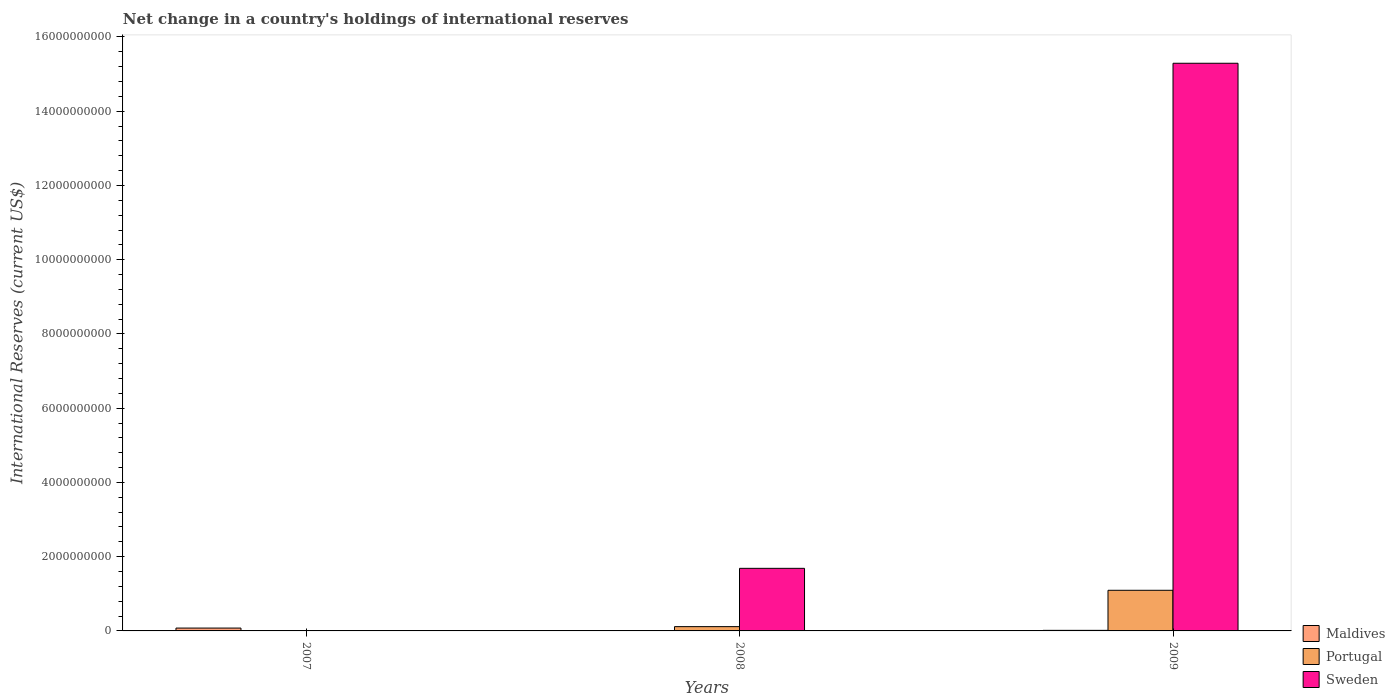Are the number of bars per tick equal to the number of legend labels?
Offer a terse response. No. How many bars are there on the 1st tick from the left?
Your answer should be very brief. 1. What is the label of the 2nd group of bars from the left?
Your answer should be very brief. 2008. What is the international reserves in Maldives in 2009?
Provide a succinct answer. 1.54e+07. Across all years, what is the maximum international reserves in Sweden?
Provide a short and direct response. 1.53e+1. Across all years, what is the minimum international reserves in Sweden?
Ensure brevity in your answer.  0. What is the total international reserves in Sweden in the graph?
Make the answer very short. 1.70e+1. What is the difference between the international reserves in Maldives in 2007 and that in 2009?
Offer a terse response. 6.13e+07. What is the difference between the international reserves in Sweden in 2008 and the international reserves in Portugal in 2009?
Offer a very short reply. 5.91e+08. What is the average international reserves in Sweden per year?
Provide a succinct answer. 5.66e+09. In the year 2009, what is the difference between the international reserves in Portugal and international reserves in Maldives?
Keep it short and to the point. 1.08e+09. Is the international reserves in Sweden in 2008 less than that in 2009?
Make the answer very short. Yes. What is the difference between the highest and the lowest international reserves in Sweden?
Offer a very short reply. 1.53e+1. Is it the case that in every year, the sum of the international reserves in Sweden and international reserves in Maldives is greater than the international reserves in Portugal?
Your answer should be compact. Yes. How many bars are there?
Offer a terse response. 6. Are all the bars in the graph horizontal?
Your answer should be compact. No. Does the graph contain any zero values?
Provide a short and direct response. Yes. How many legend labels are there?
Your answer should be compact. 3. How are the legend labels stacked?
Your answer should be compact. Vertical. What is the title of the graph?
Make the answer very short. Net change in a country's holdings of international reserves. What is the label or title of the Y-axis?
Offer a terse response. International Reserves (current US$). What is the International Reserves (current US$) in Maldives in 2007?
Your response must be concise. 7.67e+07. What is the International Reserves (current US$) of Portugal in 2007?
Your answer should be very brief. 0. What is the International Reserves (current US$) in Sweden in 2007?
Your answer should be compact. 0. What is the International Reserves (current US$) of Maldives in 2008?
Provide a succinct answer. 0. What is the International Reserves (current US$) of Portugal in 2008?
Provide a short and direct response. 1.15e+08. What is the International Reserves (current US$) in Sweden in 2008?
Your response must be concise. 1.69e+09. What is the International Reserves (current US$) in Maldives in 2009?
Make the answer very short. 1.54e+07. What is the International Reserves (current US$) in Portugal in 2009?
Offer a terse response. 1.09e+09. What is the International Reserves (current US$) in Sweden in 2009?
Provide a succinct answer. 1.53e+1. Across all years, what is the maximum International Reserves (current US$) of Maldives?
Ensure brevity in your answer.  7.67e+07. Across all years, what is the maximum International Reserves (current US$) in Portugal?
Ensure brevity in your answer.  1.09e+09. Across all years, what is the maximum International Reserves (current US$) of Sweden?
Make the answer very short. 1.53e+1. Across all years, what is the minimum International Reserves (current US$) in Maldives?
Your answer should be very brief. 0. Across all years, what is the minimum International Reserves (current US$) of Sweden?
Offer a very short reply. 0. What is the total International Reserves (current US$) of Maldives in the graph?
Give a very brief answer. 9.21e+07. What is the total International Reserves (current US$) in Portugal in the graph?
Make the answer very short. 1.21e+09. What is the total International Reserves (current US$) of Sweden in the graph?
Ensure brevity in your answer.  1.70e+1. What is the difference between the International Reserves (current US$) in Maldives in 2007 and that in 2009?
Your answer should be compact. 6.13e+07. What is the difference between the International Reserves (current US$) in Portugal in 2008 and that in 2009?
Provide a succinct answer. -9.79e+08. What is the difference between the International Reserves (current US$) of Sweden in 2008 and that in 2009?
Keep it short and to the point. -1.36e+1. What is the difference between the International Reserves (current US$) in Maldives in 2007 and the International Reserves (current US$) in Portugal in 2008?
Your answer should be very brief. -3.87e+07. What is the difference between the International Reserves (current US$) of Maldives in 2007 and the International Reserves (current US$) of Sweden in 2008?
Provide a short and direct response. -1.61e+09. What is the difference between the International Reserves (current US$) in Maldives in 2007 and the International Reserves (current US$) in Portugal in 2009?
Your answer should be compact. -1.02e+09. What is the difference between the International Reserves (current US$) in Maldives in 2007 and the International Reserves (current US$) in Sweden in 2009?
Your response must be concise. -1.52e+1. What is the difference between the International Reserves (current US$) of Portugal in 2008 and the International Reserves (current US$) of Sweden in 2009?
Your response must be concise. -1.52e+1. What is the average International Reserves (current US$) of Maldives per year?
Your answer should be compact. 3.07e+07. What is the average International Reserves (current US$) in Portugal per year?
Provide a short and direct response. 4.03e+08. What is the average International Reserves (current US$) in Sweden per year?
Provide a short and direct response. 5.66e+09. In the year 2008, what is the difference between the International Reserves (current US$) in Portugal and International Reserves (current US$) in Sweden?
Ensure brevity in your answer.  -1.57e+09. In the year 2009, what is the difference between the International Reserves (current US$) of Maldives and International Reserves (current US$) of Portugal?
Your answer should be very brief. -1.08e+09. In the year 2009, what is the difference between the International Reserves (current US$) of Maldives and International Reserves (current US$) of Sweden?
Provide a short and direct response. -1.53e+1. In the year 2009, what is the difference between the International Reserves (current US$) of Portugal and International Reserves (current US$) of Sweden?
Give a very brief answer. -1.42e+1. What is the ratio of the International Reserves (current US$) in Maldives in 2007 to that in 2009?
Ensure brevity in your answer.  4.99. What is the ratio of the International Reserves (current US$) in Portugal in 2008 to that in 2009?
Keep it short and to the point. 0.11. What is the ratio of the International Reserves (current US$) in Sweden in 2008 to that in 2009?
Your response must be concise. 0.11. What is the difference between the highest and the lowest International Reserves (current US$) of Maldives?
Provide a short and direct response. 7.67e+07. What is the difference between the highest and the lowest International Reserves (current US$) of Portugal?
Your answer should be very brief. 1.09e+09. What is the difference between the highest and the lowest International Reserves (current US$) in Sweden?
Your response must be concise. 1.53e+1. 